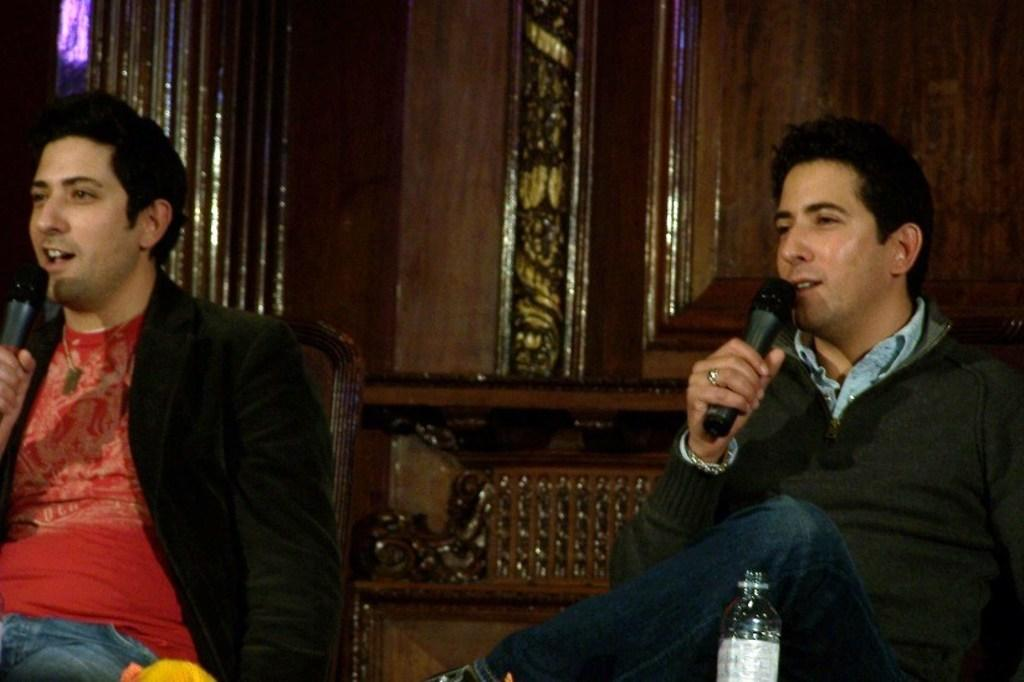How many people are in the image? There are two men in the image. What are the men doing in the image? The men are sitting on chairs and holding microphones. What object can be seen in the foreground of the image? There is a bottle in the foreground of the image. What type of surface is visible in the background of the image? There is a wooden surface visible in the background of the image. What religious symbols can be seen in the image? There are no religious symbols present in the image. What rule is being enforced by the men in the image? The men in the image are not enforcing any rules; they are holding microphones, which suggests they might be involved in a performance or presentation. 